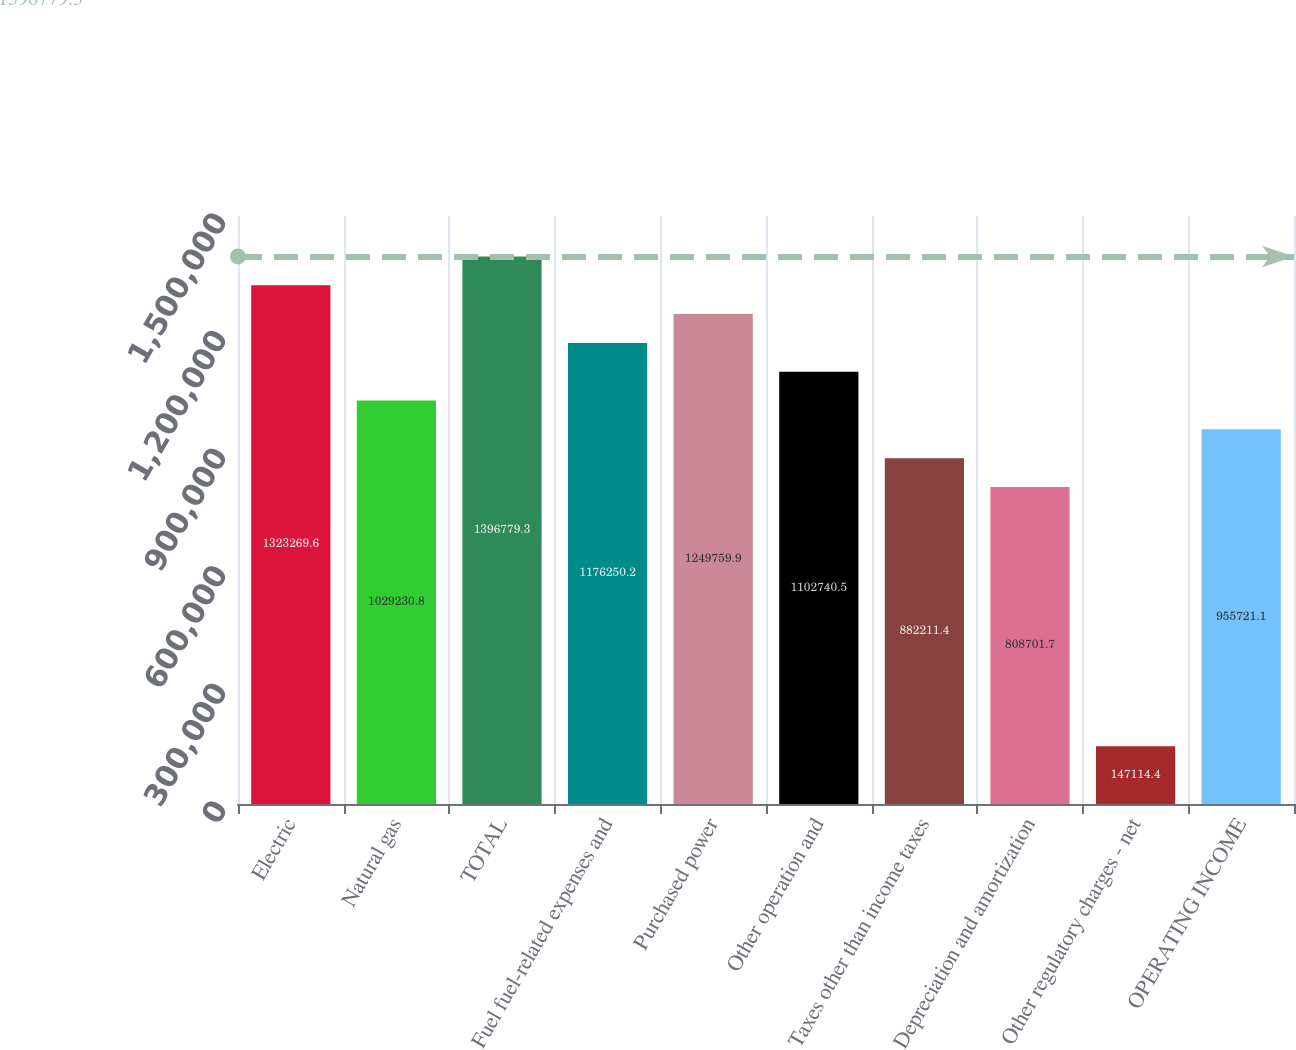Convert chart to OTSL. <chart><loc_0><loc_0><loc_500><loc_500><bar_chart><fcel>Electric<fcel>Natural gas<fcel>TOTAL<fcel>Fuel fuel-related expenses and<fcel>Purchased power<fcel>Other operation and<fcel>Taxes other than income taxes<fcel>Depreciation and amortization<fcel>Other regulatory charges - net<fcel>OPERATING INCOME<nl><fcel>1.32327e+06<fcel>1.02923e+06<fcel>1.39678e+06<fcel>1.17625e+06<fcel>1.24976e+06<fcel>1.10274e+06<fcel>882211<fcel>808702<fcel>147114<fcel>955721<nl></chart> 